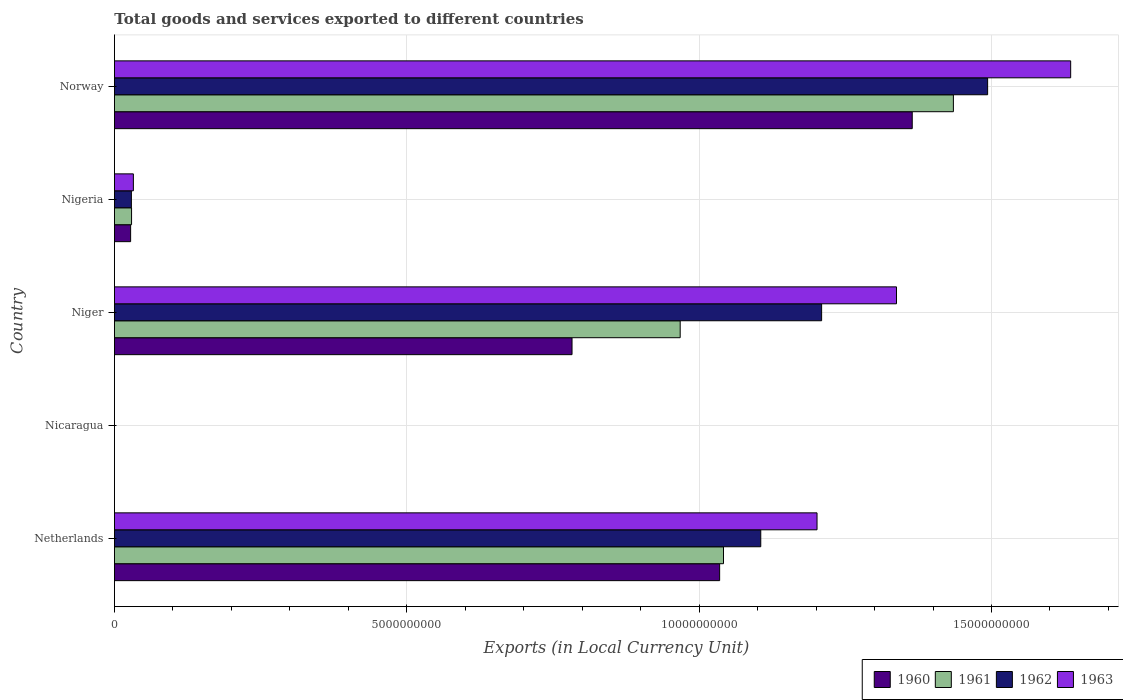How many different coloured bars are there?
Your response must be concise. 4. How many groups of bars are there?
Keep it short and to the point. 5. Are the number of bars per tick equal to the number of legend labels?
Your answer should be very brief. Yes. Are the number of bars on each tick of the Y-axis equal?
Your answer should be very brief. Yes. How many bars are there on the 4th tick from the bottom?
Keep it short and to the point. 4. What is the label of the 3rd group of bars from the top?
Ensure brevity in your answer.  Niger. What is the Amount of goods and services exports in 1961 in Nigeria?
Your response must be concise. 2.93e+08. Across all countries, what is the maximum Amount of goods and services exports in 1960?
Your response must be concise. 1.36e+1. Across all countries, what is the minimum Amount of goods and services exports in 1960?
Keep it short and to the point. 0.11. In which country was the Amount of goods and services exports in 1960 maximum?
Your answer should be compact. Norway. In which country was the Amount of goods and services exports in 1960 minimum?
Keep it short and to the point. Nicaragua. What is the total Amount of goods and services exports in 1960 in the graph?
Your response must be concise. 3.21e+1. What is the difference between the Amount of goods and services exports in 1963 in Niger and that in Norway?
Ensure brevity in your answer.  -2.98e+09. What is the difference between the Amount of goods and services exports in 1961 in Nigeria and the Amount of goods and services exports in 1960 in Nicaragua?
Give a very brief answer. 2.93e+08. What is the average Amount of goods and services exports in 1963 per country?
Keep it short and to the point. 8.41e+09. What is the difference between the Amount of goods and services exports in 1962 and Amount of goods and services exports in 1963 in Niger?
Offer a terse response. -1.28e+09. What is the ratio of the Amount of goods and services exports in 1961 in Niger to that in Norway?
Your answer should be compact. 0.67. Is the difference between the Amount of goods and services exports in 1962 in Niger and Nigeria greater than the difference between the Amount of goods and services exports in 1963 in Niger and Nigeria?
Keep it short and to the point. No. What is the difference between the highest and the second highest Amount of goods and services exports in 1960?
Offer a very short reply. 3.29e+09. What is the difference between the highest and the lowest Amount of goods and services exports in 1961?
Provide a succinct answer. 1.43e+1. How many bars are there?
Provide a short and direct response. 20. Where does the legend appear in the graph?
Keep it short and to the point. Bottom right. What is the title of the graph?
Your answer should be very brief. Total goods and services exported to different countries. What is the label or title of the X-axis?
Your response must be concise. Exports (in Local Currency Unit). What is the label or title of the Y-axis?
Your response must be concise. Country. What is the Exports (in Local Currency Unit) of 1960 in Netherlands?
Give a very brief answer. 1.04e+1. What is the Exports (in Local Currency Unit) of 1961 in Netherlands?
Provide a short and direct response. 1.04e+1. What is the Exports (in Local Currency Unit) of 1962 in Netherlands?
Keep it short and to the point. 1.11e+1. What is the Exports (in Local Currency Unit) in 1963 in Netherlands?
Give a very brief answer. 1.20e+1. What is the Exports (in Local Currency Unit) in 1960 in Nicaragua?
Your answer should be very brief. 0.11. What is the Exports (in Local Currency Unit) in 1961 in Nicaragua?
Make the answer very short. 0.12. What is the Exports (in Local Currency Unit) of 1962 in Nicaragua?
Offer a very short reply. 0.15. What is the Exports (in Local Currency Unit) in 1963 in Nicaragua?
Keep it short and to the point. 0.18. What is the Exports (in Local Currency Unit) in 1960 in Niger?
Offer a very short reply. 7.83e+09. What is the Exports (in Local Currency Unit) of 1961 in Niger?
Your response must be concise. 9.68e+09. What is the Exports (in Local Currency Unit) in 1962 in Niger?
Your answer should be very brief. 1.21e+1. What is the Exports (in Local Currency Unit) of 1963 in Niger?
Your response must be concise. 1.34e+1. What is the Exports (in Local Currency Unit) in 1960 in Nigeria?
Offer a very short reply. 2.77e+08. What is the Exports (in Local Currency Unit) of 1961 in Nigeria?
Give a very brief answer. 2.93e+08. What is the Exports (in Local Currency Unit) in 1962 in Nigeria?
Provide a succinct answer. 2.90e+08. What is the Exports (in Local Currency Unit) in 1963 in Nigeria?
Provide a succinct answer. 3.24e+08. What is the Exports (in Local Currency Unit) of 1960 in Norway?
Keep it short and to the point. 1.36e+1. What is the Exports (in Local Currency Unit) of 1961 in Norway?
Offer a very short reply. 1.43e+1. What is the Exports (in Local Currency Unit) of 1962 in Norway?
Make the answer very short. 1.49e+1. What is the Exports (in Local Currency Unit) of 1963 in Norway?
Offer a terse response. 1.64e+1. Across all countries, what is the maximum Exports (in Local Currency Unit) in 1960?
Provide a succinct answer. 1.36e+1. Across all countries, what is the maximum Exports (in Local Currency Unit) in 1961?
Give a very brief answer. 1.43e+1. Across all countries, what is the maximum Exports (in Local Currency Unit) of 1962?
Make the answer very short. 1.49e+1. Across all countries, what is the maximum Exports (in Local Currency Unit) in 1963?
Your response must be concise. 1.64e+1. Across all countries, what is the minimum Exports (in Local Currency Unit) in 1960?
Provide a short and direct response. 0.11. Across all countries, what is the minimum Exports (in Local Currency Unit) in 1961?
Provide a short and direct response. 0.12. Across all countries, what is the minimum Exports (in Local Currency Unit) in 1962?
Offer a very short reply. 0.15. Across all countries, what is the minimum Exports (in Local Currency Unit) in 1963?
Give a very brief answer. 0.18. What is the total Exports (in Local Currency Unit) in 1960 in the graph?
Your answer should be very brief. 3.21e+1. What is the total Exports (in Local Currency Unit) in 1961 in the graph?
Make the answer very short. 3.47e+1. What is the total Exports (in Local Currency Unit) of 1962 in the graph?
Your answer should be very brief. 3.84e+1. What is the total Exports (in Local Currency Unit) of 1963 in the graph?
Offer a terse response. 4.21e+1. What is the difference between the Exports (in Local Currency Unit) in 1960 in Netherlands and that in Nicaragua?
Keep it short and to the point. 1.04e+1. What is the difference between the Exports (in Local Currency Unit) of 1961 in Netherlands and that in Nicaragua?
Keep it short and to the point. 1.04e+1. What is the difference between the Exports (in Local Currency Unit) of 1962 in Netherlands and that in Nicaragua?
Your answer should be very brief. 1.11e+1. What is the difference between the Exports (in Local Currency Unit) in 1963 in Netherlands and that in Nicaragua?
Your answer should be very brief. 1.20e+1. What is the difference between the Exports (in Local Currency Unit) in 1960 in Netherlands and that in Niger?
Provide a succinct answer. 2.52e+09. What is the difference between the Exports (in Local Currency Unit) in 1961 in Netherlands and that in Niger?
Your response must be concise. 7.41e+08. What is the difference between the Exports (in Local Currency Unit) in 1962 in Netherlands and that in Niger?
Your answer should be compact. -1.04e+09. What is the difference between the Exports (in Local Currency Unit) of 1963 in Netherlands and that in Niger?
Your response must be concise. -1.36e+09. What is the difference between the Exports (in Local Currency Unit) of 1960 in Netherlands and that in Nigeria?
Your answer should be compact. 1.01e+1. What is the difference between the Exports (in Local Currency Unit) of 1961 in Netherlands and that in Nigeria?
Ensure brevity in your answer.  1.01e+1. What is the difference between the Exports (in Local Currency Unit) of 1962 in Netherlands and that in Nigeria?
Give a very brief answer. 1.08e+1. What is the difference between the Exports (in Local Currency Unit) in 1963 in Netherlands and that in Nigeria?
Provide a succinct answer. 1.17e+1. What is the difference between the Exports (in Local Currency Unit) of 1960 in Netherlands and that in Norway?
Give a very brief answer. -3.29e+09. What is the difference between the Exports (in Local Currency Unit) in 1961 in Netherlands and that in Norway?
Offer a terse response. -3.93e+09. What is the difference between the Exports (in Local Currency Unit) in 1962 in Netherlands and that in Norway?
Give a very brief answer. -3.88e+09. What is the difference between the Exports (in Local Currency Unit) in 1963 in Netherlands and that in Norway?
Give a very brief answer. -4.34e+09. What is the difference between the Exports (in Local Currency Unit) in 1960 in Nicaragua and that in Niger?
Your response must be concise. -7.83e+09. What is the difference between the Exports (in Local Currency Unit) of 1961 in Nicaragua and that in Niger?
Your answer should be compact. -9.68e+09. What is the difference between the Exports (in Local Currency Unit) of 1962 in Nicaragua and that in Niger?
Provide a short and direct response. -1.21e+1. What is the difference between the Exports (in Local Currency Unit) of 1963 in Nicaragua and that in Niger?
Keep it short and to the point. -1.34e+1. What is the difference between the Exports (in Local Currency Unit) in 1960 in Nicaragua and that in Nigeria?
Offer a terse response. -2.77e+08. What is the difference between the Exports (in Local Currency Unit) in 1961 in Nicaragua and that in Nigeria?
Make the answer very short. -2.93e+08. What is the difference between the Exports (in Local Currency Unit) of 1962 in Nicaragua and that in Nigeria?
Provide a succinct answer. -2.90e+08. What is the difference between the Exports (in Local Currency Unit) in 1963 in Nicaragua and that in Nigeria?
Your answer should be compact. -3.24e+08. What is the difference between the Exports (in Local Currency Unit) in 1960 in Nicaragua and that in Norway?
Provide a succinct answer. -1.36e+1. What is the difference between the Exports (in Local Currency Unit) of 1961 in Nicaragua and that in Norway?
Provide a short and direct response. -1.43e+1. What is the difference between the Exports (in Local Currency Unit) of 1962 in Nicaragua and that in Norway?
Provide a short and direct response. -1.49e+1. What is the difference between the Exports (in Local Currency Unit) in 1963 in Nicaragua and that in Norway?
Ensure brevity in your answer.  -1.64e+1. What is the difference between the Exports (in Local Currency Unit) of 1960 in Niger and that in Nigeria?
Offer a very short reply. 7.55e+09. What is the difference between the Exports (in Local Currency Unit) in 1961 in Niger and that in Nigeria?
Offer a terse response. 9.38e+09. What is the difference between the Exports (in Local Currency Unit) in 1962 in Niger and that in Nigeria?
Offer a terse response. 1.18e+1. What is the difference between the Exports (in Local Currency Unit) in 1963 in Niger and that in Nigeria?
Offer a terse response. 1.31e+1. What is the difference between the Exports (in Local Currency Unit) of 1960 in Niger and that in Norway?
Provide a succinct answer. -5.82e+09. What is the difference between the Exports (in Local Currency Unit) in 1961 in Niger and that in Norway?
Ensure brevity in your answer.  -4.67e+09. What is the difference between the Exports (in Local Currency Unit) of 1962 in Niger and that in Norway?
Your answer should be compact. -2.84e+09. What is the difference between the Exports (in Local Currency Unit) of 1963 in Niger and that in Norway?
Give a very brief answer. -2.98e+09. What is the difference between the Exports (in Local Currency Unit) of 1960 in Nigeria and that in Norway?
Keep it short and to the point. -1.34e+1. What is the difference between the Exports (in Local Currency Unit) of 1961 in Nigeria and that in Norway?
Your answer should be very brief. -1.41e+1. What is the difference between the Exports (in Local Currency Unit) in 1962 in Nigeria and that in Norway?
Keep it short and to the point. -1.46e+1. What is the difference between the Exports (in Local Currency Unit) in 1963 in Nigeria and that in Norway?
Your response must be concise. -1.60e+1. What is the difference between the Exports (in Local Currency Unit) of 1960 in Netherlands and the Exports (in Local Currency Unit) of 1961 in Nicaragua?
Offer a terse response. 1.04e+1. What is the difference between the Exports (in Local Currency Unit) of 1960 in Netherlands and the Exports (in Local Currency Unit) of 1962 in Nicaragua?
Provide a succinct answer. 1.04e+1. What is the difference between the Exports (in Local Currency Unit) of 1960 in Netherlands and the Exports (in Local Currency Unit) of 1963 in Nicaragua?
Keep it short and to the point. 1.04e+1. What is the difference between the Exports (in Local Currency Unit) in 1961 in Netherlands and the Exports (in Local Currency Unit) in 1962 in Nicaragua?
Offer a very short reply. 1.04e+1. What is the difference between the Exports (in Local Currency Unit) in 1961 in Netherlands and the Exports (in Local Currency Unit) in 1963 in Nicaragua?
Your response must be concise. 1.04e+1. What is the difference between the Exports (in Local Currency Unit) in 1962 in Netherlands and the Exports (in Local Currency Unit) in 1963 in Nicaragua?
Provide a short and direct response. 1.11e+1. What is the difference between the Exports (in Local Currency Unit) in 1960 in Netherlands and the Exports (in Local Currency Unit) in 1961 in Niger?
Make the answer very short. 6.75e+08. What is the difference between the Exports (in Local Currency Unit) of 1960 in Netherlands and the Exports (in Local Currency Unit) of 1962 in Niger?
Offer a very short reply. -1.74e+09. What is the difference between the Exports (in Local Currency Unit) in 1960 in Netherlands and the Exports (in Local Currency Unit) in 1963 in Niger?
Your answer should be compact. -3.02e+09. What is the difference between the Exports (in Local Currency Unit) of 1961 in Netherlands and the Exports (in Local Currency Unit) of 1962 in Niger?
Your response must be concise. -1.68e+09. What is the difference between the Exports (in Local Currency Unit) in 1961 in Netherlands and the Exports (in Local Currency Unit) in 1963 in Niger?
Keep it short and to the point. -2.96e+09. What is the difference between the Exports (in Local Currency Unit) in 1962 in Netherlands and the Exports (in Local Currency Unit) in 1963 in Niger?
Your response must be concise. -2.32e+09. What is the difference between the Exports (in Local Currency Unit) of 1960 in Netherlands and the Exports (in Local Currency Unit) of 1961 in Nigeria?
Make the answer very short. 1.01e+1. What is the difference between the Exports (in Local Currency Unit) in 1960 in Netherlands and the Exports (in Local Currency Unit) in 1962 in Nigeria?
Offer a terse response. 1.01e+1. What is the difference between the Exports (in Local Currency Unit) of 1960 in Netherlands and the Exports (in Local Currency Unit) of 1963 in Nigeria?
Your response must be concise. 1.00e+1. What is the difference between the Exports (in Local Currency Unit) in 1961 in Netherlands and the Exports (in Local Currency Unit) in 1962 in Nigeria?
Provide a succinct answer. 1.01e+1. What is the difference between the Exports (in Local Currency Unit) in 1961 in Netherlands and the Exports (in Local Currency Unit) in 1963 in Nigeria?
Keep it short and to the point. 1.01e+1. What is the difference between the Exports (in Local Currency Unit) of 1962 in Netherlands and the Exports (in Local Currency Unit) of 1963 in Nigeria?
Your response must be concise. 1.07e+1. What is the difference between the Exports (in Local Currency Unit) in 1960 in Netherlands and the Exports (in Local Currency Unit) in 1961 in Norway?
Give a very brief answer. -4.00e+09. What is the difference between the Exports (in Local Currency Unit) of 1960 in Netherlands and the Exports (in Local Currency Unit) of 1962 in Norway?
Keep it short and to the point. -4.58e+09. What is the difference between the Exports (in Local Currency Unit) of 1960 in Netherlands and the Exports (in Local Currency Unit) of 1963 in Norway?
Keep it short and to the point. -6.00e+09. What is the difference between the Exports (in Local Currency Unit) of 1961 in Netherlands and the Exports (in Local Currency Unit) of 1962 in Norway?
Offer a very short reply. -4.52e+09. What is the difference between the Exports (in Local Currency Unit) of 1961 in Netherlands and the Exports (in Local Currency Unit) of 1963 in Norway?
Offer a very short reply. -5.94e+09. What is the difference between the Exports (in Local Currency Unit) in 1962 in Netherlands and the Exports (in Local Currency Unit) in 1963 in Norway?
Your answer should be very brief. -5.30e+09. What is the difference between the Exports (in Local Currency Unit) of 1960 in Nicaragua and the Exports (in Local Currency Unit) of 1961 in Niger?
Offer a terse response. -9.68e+09. What is the difference between the Exports (in Local Currency Unit) in 1960 in Nicaragua and the Exports (in Local Currency Unit) in 1962 in Niger?
Your answer should be very brief. -1.21e+1. What is the difference between the Exports (in Local Currency Unit) of 1960 in Nicaragua and the Exports (in Local Currency Unit) of 1963 in Niger?
Your answer should be very brief. -1.34e+1. What is the difference between the Exports (in Local Currency Unit) in 1961 in Nicaragua and the Exports (in Local Currency Unit) in 1962 in Niger?
Provide a succinct answer. -1.21e+1. What is the difference between the Exports (in Local Currency Unit) in 1961 in Nicaragua and the Exports (in Local Currency Unit) in 1963 in Niger?
Keep it short and to the point. -1.34e+1. What is the difference between the Exports (in Local Currency Unit) of 1962 in Nicaragua and the Exports (in Local Currency Unit) of 1963 in Niger?
Your answer should be compact. -1.34e+1. What is the difference between the Exports (in Local Currency Unit) of 1960 in Nicaragua and the Exports (in Local Currency Unit) of 1961 in Nigeria?
Provide a short and direct response. -2.93e+08. What is the difference between the Exports (in Local Currency Unit) of 1960 in Nicaragua and the Exports (in Local Currency Unit) of 1962 in Nigeria?
Your answer should be compact. -2.90e+08. What is the difference between the Exports (in Local Currency Unit) of 1960 in Nicaragua and the Exports (in Local Currency Unit) of 1963 in Nigeria?
Your answer should be compact. -3.24e+08. What is the difference between the Exports (in Local Currency Unit) of 1961 in Nicaragua and the Exports (in Local Currency Unit) of 1962 in Nigeria?
Offer a terse response. -2.90e+08. What is the difference between the Exports (in Local Currency Unit) of 1961 in Nicaragua and the Exports (in Local Currency Unit) of 1963 in Nigeria?
Offer a very short reply. -3.24e+08. What is the difference between the Exports (in Local Currency Unit) in 1962 in Nicaragua and the Exports (in Local Currency Unit) in 1963 in Nigeria?
Offer a terse response. -3.24e+08. What is the difference between the Exports (in Local Currency Unit) in 1960 in Nicaragua and the Exports (in Local Currency Unit) in 1961 in Norway?
Your answer should be compact. -1.43e+1. What is the difference between the Exports (in Local Currency Unit) of 1960 in Nicaragua and the Exports (in Local Currency Unit) of 1962 in Norway?
Offer a very short reply. -1.49e+1. What is the difference between the Exports (in Local Currency Unit) in 1960 in Nicaragua and the Exports (in Local Currency Unit) in 1963 in Norway?
Ensure brevity in your answer.  -1.64e+1. What is the difference between the Exports (in Local Currency Unit) of 1961 in Nicaragua and the Exports (in Local Currency Unit) of 1962 in Norway?
Provide a short and direct response. -1.49e+1. What is the difference between the Exports (in Local Currency Unit) in 1961 in Nicaragua and the Exports (in Local Currency Unit) in 1963 in Norway?
Provide a succinct answer. -1.64e+1. What is the difference between the Exports (in Local Currency Unit) of 1962 in Nicaragua and the Exports (in Local Currency Unit) of 1963 in Norway?
Give a very brief answer. -1.64e+1. What is the difference between the Exports (in Local Currency Unit) in 1960 in Niger and the Exports (in Local Currency Unit) in 1961 in Nigeria?
Keep it short and to the point. 7.53e+09. What is the difference between the Exports (in Local Currency Unit) of 1960 in Niger and the Exports (in Local Currency Unit) of 1962 in Nigeria?
Your response must be concise. 7.54e+09. What is the difference between the Exports (in Local Currency Unit) of 1960 in Niger and the Exports (in Local Currency Unit) of 1963 in Nigeria?
Your answer should be compact. 7.50e+09. What is the difference between the Exports (in Local Currency Unit) of 1961 in Niger and the Exports (in Local Currency Unit) of 1962 in Nigeria?
Provide a succinct answer. 9.39e+09. What is the difference between the Exports (in Local Currency Unit) in 1961 in Niger and the Exports (in Local Currency Unit) in 1963 in Nigeria?
Your response must be concise. 9.35e+09. What is the difference between the Exports (in Local Currency Unit) of 1962 in Niger and the Exports (in Local Currency Unit) of 1963 in Nigeria?
Provide a succinct answer. 1.18e+1. What is the difference between the Exports (in Local Currency Unit) of 1960 in Niger and the Exports (in Local Currency Unit) of 1961 in Norway?
Provide a succinct answer. -6.52e+09. What is the difference between the Exports (in Local Currency Unit) in 1960 in Niger and the Exports (in Local Currency Unit) in 1962 in Norway?
Ensure brevity in your answer.  -7.11e+09. What is the difference between the Exports (in Local Currency Unit) of 1960 in Niger and the Exports (in Local Currency Unit) of 1963 in Norway?
Ensure brevity in your answer.  -8.53e+09. What is the difference between the Exports (in Local Currency Unit) in 1961 in Niger and the Exports (in Local Currency Unit) in 1962 in Norway?
Ensure brevity in your answer.  -5.26e+09. What is the difference between the Exports (in Local Currency Unit) in 1961 in Niger and the Exports (in Local Currency Unit) in 1963 in Norway?
Your answer should be very brief. -6.68e+09. What is the difference between the Exports (in Local Currency Unit) in 1962 in Niger and the Exports (in Local Currency Unit) in 1963 in Norway?
Give a very brief answer. -4.26e+09. What is the difference between the Exports (in Local Currency Unit) in 1960 in Nigeria and the Exports (in Local Currency Unit) in 1961 in Norway?
Provide a succinct answer. -1.41e+1. What is the difference between the Exports (in Local Currency Unit) of 1960 in Nigeria and the Exports (in Local Currency Unit) of 1962 in Norway?
Make the answer very short. -1.47e+1. What is the difference between the Exports (in Local Currency Unit) in 1960 in Nigeria and the Exports (in Local Currency Unit) in 1963 in Norway?
Your answer should be very brief. -1.61e+1. What is the difference between the Exports (in Local Currency Unit) of 1961 in Nigeria and the Exports (in Local Currency Unit) of 1962 in Norway?
Give a very brief answer. -1.46e+1. What is the difference between the Exports (in Local Currency Unit) in 1961 in Nigeria and the Exports (in Local Currency Unit) in 1963 in Norway?
Keep it short and to the point. -1.61e+1. What is the difference between the Exports (in Local Currency Unit) in 1962 in Nigeria and the Exports (in Local Currency Unit) in 1963 in Norway?
Keep it short and to the point. -1.61e+1. What is the average Exports (in Local Currency Unit) of 1960 per country?
Offer a very short reply. 6.42e+09. What is the average Exports (in Local Currency Unit) in 1961 per country?
Provide a succinct answer. 6.95e+09. What is the average Exports (in Local Currency Unit) in 1962 per country?
Offer a terse response. 7.67e+09. What is the average Exports (in Local Currency Unit) of 1963 per country?
Your answer should be very brief. 8.41e+09. What is the difference between the Exports (in Local Currency Unit) in 1960 and Exports (in Local Currency Unit) in 1961 in Netherlands?
Make the answer very short. -6.60e+07. What is the difference between the Exports (in Local Currency Unit) in 1960 and Exports (in Local Currency Unit) in 1962 in Netherlands?
Give a very brief answer. -7.03e+08. What is the difference between the Exports (in Local Currency Unit) in 1960 and Exports (in Local Currency Unit) in 1963 in Netherlands?
Keep it short and to the point. -1.67e+09. What is the difference between the Exports (in Local Currency Unit) in 1961 and Exports (in Local Currency Unit) in 1962 in Netherlands?
Your answer should be compact. -6.37e+08. What is the difference between the Exports (in Local Currency Unit) in 1961 and Exports (in Local Currency Unit) in 1963 in Netherlands?
Ensure brevity in your answer.  -1.60e+09. What is the difference between the Exports (in Local Currency Unit) in 1962 and Exports (in Local Currency Unit) in 1963 in Netherlands?
Ensure brevity in your answer.  -9.62e+08. What is the difference between the Exports (in Local Currency Unit) in 1960 and Exports (in Local Currency Unit) in 1961 in Nicaragua?
Keep it short and to the point. -0.01. What is the difference between the Exports (in Local Currency Unit) of 1960 and Exports (in Local Currency Unit) of 1962 in Nicaragua?
Ensure brevity in your answer.  -0.04. What is the difference between the Exports (in Local Currency Unit) of 1960 and Exports (in Local Currency Unit) of 1963 in Nicaragua?
Your response must be concise. -0.07. What is the difference between the Exports (in Local Currency Unit) of 1961 and Exports (in Local Currency Unit) of 1962 in Nicaragua?
Give a very brief answer. -0.03. What is the difference between the Exports (in Local Currency Unit) in 1961 and Exports (in Local Currency Unit) in 1963 in Nicaragua?
Make the answer very short. -0.06. What is the difference between the Exports (in Local Currency Unit) in 1962 and Exports (in Local Currency Unit) in 1963 in Nicaragua?
Provide a succinct answer. -0.03. What is the difference between the Exports (in Local Currency Unit) in 1960 and Exports (in Local Currency Unit) in 1961 in Niger?
Provide a short and direct response. -1.85e+09. What is the difference between the Exports (in Local Currency Unit) in 1960 and Exports (in Local Currency Unit) in 1962 in Niger?
Give a very brief answer. -4.27e+09. What is the difference between the Exports (in Local Currency Unit) of 1960 and Exports (in Local Currency Unit) of 1963 in Niger?
Keep it short and to the point. -5.55e+09. What is the difference between the Exports (in Local Currency Unit) of 1961 and Exports (in Local Currency Unit) of 1962 in Niger?
Give a very brief answer. -2.42e+09. What is the difference between the Exports (in Local Currency Unit) in 1961 and Exports (in Local Currency Unit) in 1963 in Niger?
Keep it short and to the point. -3.70e+09. What is the difference between the Exports (in Local Currency Unit) in 1962 and Exports (in Local Currency Unit) in 1963 in Niger?
Make the answer very short. -1.28e+09. What is the difference between the Exports (in Local Currency Unit) of 1960 and Exports (in Local Currency Unit) of 1961 in Nigeria?
Your answer should be compact. -1.61e+07. What is the difference between the Exports (in Local Currency Unit) in 1960 and Exports (in Local Currency Unit) in 1962 in Nigeria?
Ensure brevity in your answer.  -1.30e+07. What is the difference between the Exports (in Local Currency Unit) of 1960 and Exports (in Local Currency Unit) of 1963 in Nigeria?
Keep it short and to the point. -4.69e+07. What is the difference between the Exports (in Local Currency Unit) of 1961 and Exports (in Local Currency Unit) of 1962 in Nigeria?
Give a very brief answer. 3.12e+06. What is the difference between the Exports (in Local Currency Unit) in 1961 and Exports (in Local Currency Unit) in 1963 in Nigeria?
Provide a short and direct response. -3.08e+07. What is the difference between the Exports (in Local Currency Unit) of 1962 and Exports (in Local Currency Unit) of 1963 in Nigeria?
Keep it short and to the point. -3.40e+07. What is the difference between the Exports (in Local Currency Unit) of 1960 and Exports (in Local Currency Unit) of 1961 in Norway?
Ensure brevity in your answer.  -7.04e+08. What is the difference between the Exports (in Local Currency Unit) of 1960 and Exports (in Local Currency Unit) of 1962 in Norway?
Give a very brief answer. -1.29e+09. What is the difference between the Exports (in Local Currency Unit) in 1960 and Exports (in Local Currency Unit) in 1963 in Norway?
Your answer should be compact. -2.71e+09. What is the difference between the Exports (in Local Currency Unit) of 1961 and Exports (in Local Currency Unit) of 1962 in Norway?
Ensure brevity in your answer.  -5.86e+08. What is the difference between the Exports (in Local Currency Unit) in 1961 and Exports (in Local Currency Unit) in 1963 in Norway?
Keep it short and to the point. -2.01e+09. What is the difference between the Exports (in Local Currency Unit) of 1962 and Exports (in Local Currency Unit) of 1963 in Norway?
Provide a short and direct response. -1.42e+09. What is the ratio of the Exports (in Local Currency Unit) of 1960 in Netherlands to that in Nicaragua?
Give a very brief answer. 9.31e+1. What is the ratio of the Exports (in Local Currency Unit) in 1961 in Netherlands to that in Nicaragua?
Your response must be concise. 8.81e+1. What is the ratio of the Exports (in Local Currency Unit) in 1962 in Netherlands to that in Nicaragua?
Offer a terse response. 7.51e+1. What is the ratio of the Exports (in Local Currency Unit) of 1963 in Netherlands to that in Nicaragua?
Ensure brevity in your answer.  6.78e+1. What is the ratio of the Exports (in Local Currency Unit) of 1960 in Netherlands to that in Niger?
Provide a succinct answer. 1.32. What is the ratio of the Exports (in Local Currency Unit) in 1961 in Netherlands to that in Niger?
Your answer should be compact. 1.08. What is the ratio of the Exports (in Local Currency Unit) in 1962 in Netherlands to that in Niger?
Give a very brief answer. 0.91. What is the ratio of the Exports (in Local Currency Unit) in 1963 in Netherlands to that in Niger?
Your response must be concise. 0.9. What is the ratio of the Exports (in Local Currency Unit) in 1960 in Netherlands to that in Nigeria?
Make the answer very short. 37.37. What is the ratio of the Exports (in Local Currency Unit) of 1961 in Netherlands to that in Nigeria?
Your answer should be very brief. 35.54. What is the ratio of the Exports (in Local Currency Unit) in 1962 in Netherlands to that in Nigeria?
Ensure brevity in your answer.  38.12. What is the ratio of the Exports (in Local Currency Unit) of 1963 in Netherlands to that in Nigeria?
Provide a short and direct response. 37.1. What is the ratio of the Exports (in Local Currency Unit) in 1960 in Netherlands to that in Norway?
Provide a succinct answer. 0.76. What is the ratio of the Exports (in Local Currency Unit) of 1961 in Netherlands to that in Norway?
Make the answer very short. 0.73. What is the ratio of the Exports (in Local Currency Unit) in 1962 in Netherlands to that in Norway?
Offer a terse response. 0.74. What is the ratio of the Exports (in Local Currency Unit) in 1963 in Netherlands to that in Norway?
Keep it short and to the point. 0.73. What is the ratio of the Exports (in Local Currency Unit) of 1960 in Nicaragua to that in Niger?
Make the answer very short. 0. What is the ratio of the Exports (in Local Currency Unit) in 1961 in Nicaragua to that in Niger?
Offer a very short reply. 0. What is the ratio of the Exports (in Local Currency Unit) of 1962 in Nicaragua to that in Niger?
Your answer should be very brief. 0. What is the ratio of the Exports (in Local Currency Unit) in 1961 in Nicaragua to that in Nigeria?
Make the answer very short. 0. What is the ratio of the Exports (in Local Currency Unit) of 1962 in Nicaragua to that in Nigeria?
Give a very brief answer. 0. What is the ratio of the Exports (in Local Currency Unit) of 1960 in Nicaragua to that in Norway?
Provide a short and direct response. 0. What is the ratio of the Exports (in Local Currency Unit) in 1962 in Nicaragua to that in Norway?
Your answer should be very brief. 0. What is the ratio of the Exports (in Local Currency Unit) of 1960 in Niger to that in Nigeria?
Provide a short and direct response. 28.25. What is the ratio of the Exports (in Local Currency Unit) in 1961 in Niger to that in Nigeria?
Provide a short and direct response. 33.01. What is the ratio of the Exports (in Local Currency Unit) of 1962 in Niger to that in Nigeria?
Your answer should be compact. 41.71. What is the ratio of the Exports (in Local Currency Unit) in 1963 in Niger to that in Nigeria?
Provide a short and direct response. 41.29. What is the ratio of the Exports (in Local Currency Unit) of 1960 in Niger to that in Norway?
Your answer should be very brief. 0.57. What is the ratio of the Exports (in Local Currency Unit) of 1961 in Niger to that in Norway?
Your answer should be compact. 0.67. What is the ratio of the Exports (in Local Currency Unit) of 1962 in Niger to that in Norway?
Offer a terse response. 0.81. What is the ratio of the Exports (in Local Currency Unit) in 1963 in Niger to that in Norway?
Your answer should be very brief. 0.82. What is the ratio of the Exports (in Local Currency Unit) of 1960 in Nigeria to that in Norway?
Your answer should be compact. 0.02. What is the ratio of the Exports (in Local Currency Unit) in 1961 in Nigeria to that in Norway?
Offer a terse response. 0.02. What is the ratio of the Exports (in Local Currency Unit) of 1962 in Nigeria to that in Norway?
Offer a very short reply. 0.02. What is the ratio of the Exports (in Local Currency Unit) in 1963 in Nigeria to that in Norway?
Keep it short and to the point. 0.02. What is the difference between the highest and the second highest Exports (in Local Currency Unit) in 1960?
Your response must be concise. 3.29e+09. What is the difference between the highest and the second highest Exports (in Local Currency Unit) in 1961?
Give a very brief answer. 3.93e+09. What is the difference between the highest and the second highest Exports (in Local Currency Unit) of 1962?
Provide a short and direct response. 2.84e+09. What is the difference between the highest and the second highest Exports (in Local Currency Unit) in 1963?
Offer a very short reply. 2.98e+09. What is the difference between the highest and the lowest Exports (in Local Currency Unit) in 1960?
Your answer should be very brief. 1.36e+1. What is the difference between the highest and the lowest Exports (in Local Currency Unit) in 1961?
Offer a very short reply. 1.43e+1. What is the difference between the highest and the lowest Exports (in Local Currency Unit) of 1962?
Offer a very short reply. 1.49e+1. What is the difference between the highest and the lowest Exports (in Local Currency Unit) in 1963?
Ensure brevity in your answer.  1.64e+1. 